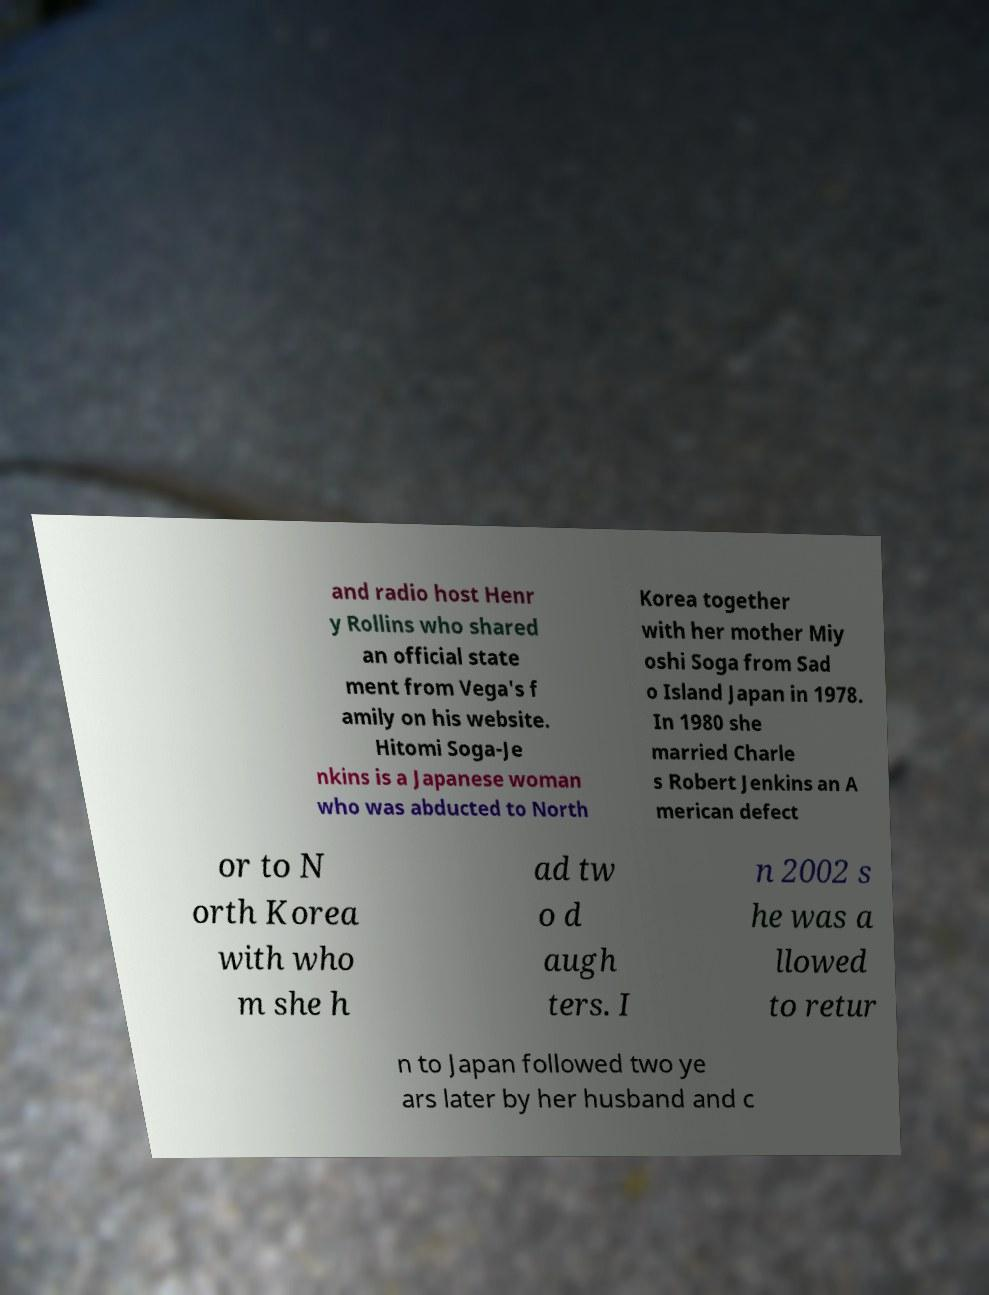Can you read and provide the text displayed in the image?This photo seems to have some interesting text. Can you extract and type it out for me? and radio host Henr y Rollins who shared an official state ment from Vega's f amily on his website. Hitomi Soga-Je nkins is a Japanese woman who was abducted to North Korea together with her mother Miy oshi Soga from Sad o Island Japan in 1978. In 1980 she married Charle s Robert Jenkins an A merican defect or to N orth Korea with who m she h ad tw o d augh ters. I n 2002 s he was a llowed to retur n to Japan followed two ye ars later by her husband and c 